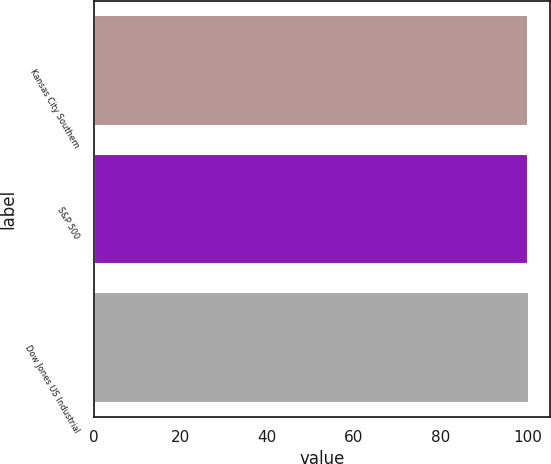<chart> <loc_0><loc_0><loc_500><loc_500><bar_chart><fcel>Kansas City Southern<fcel>S&P 500<fcel>Dow Jones US Industrial<nl><fcel>100<fcel>100.1<fcel>100.2<nl></chart> 